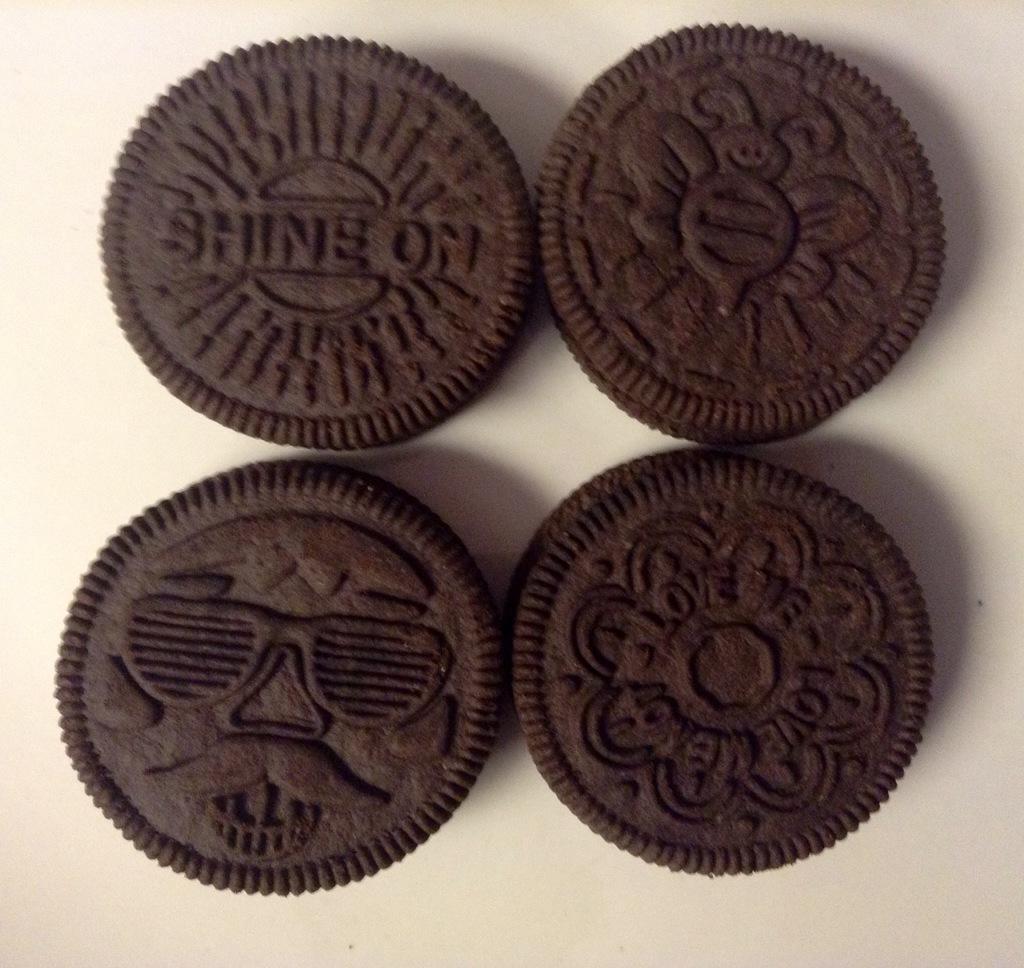Describe this image in one or two sentences. In this image there are four chocolate biscuits in the middle. 